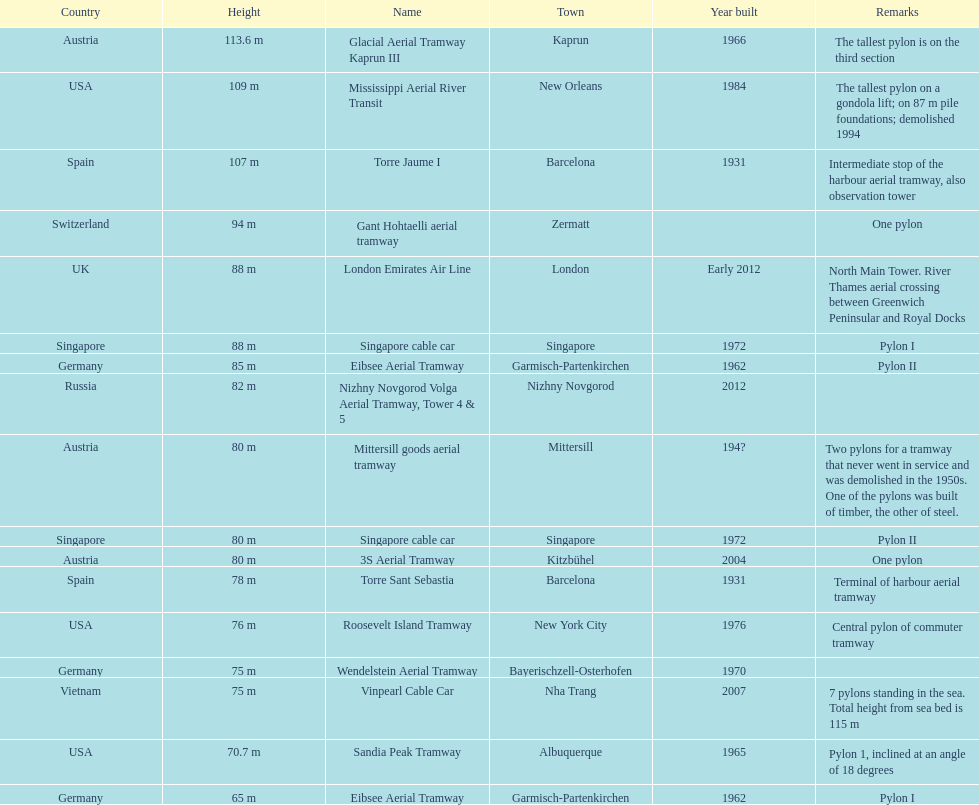How many pylons are in austria? 3. 